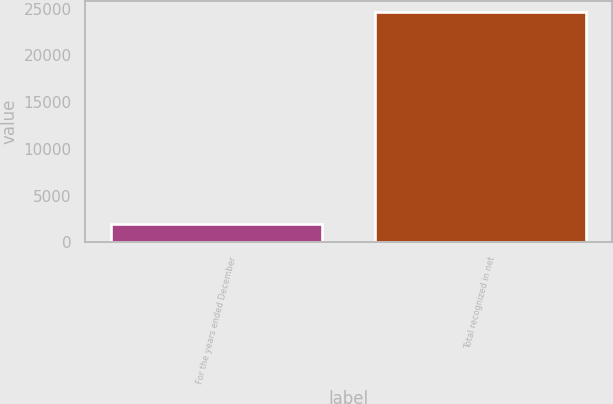<chart> <loc_0><loc_0><loc_500><loc_500><bar_chart><fcel>For the years ended December<fcel>Total recognized in net<nl><fcel>2005<fcel>24624<nl></chart> 